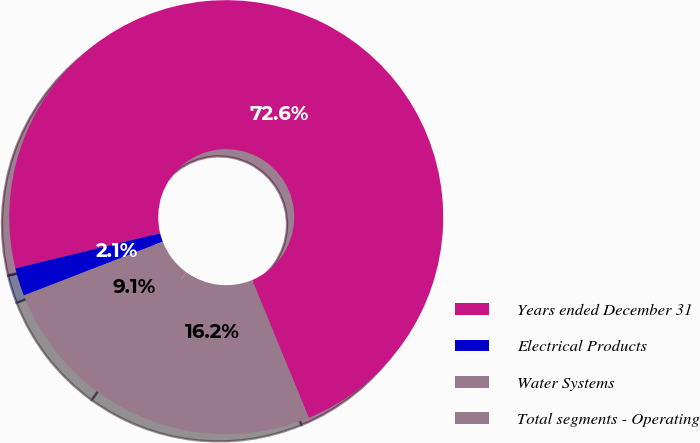Convert chart to OTSL. <chart><loc_0><loc_0><loc_500><loc_500><pie_chart><fcel>Years ended December 31<fcel>Electrical Products<fcel>Water Systems<fcel>Total segments - Operating<nl><fcel>72.59%<fcel>2.09%<fcel>9.14%<fcel>16.19%<nl></chart> 